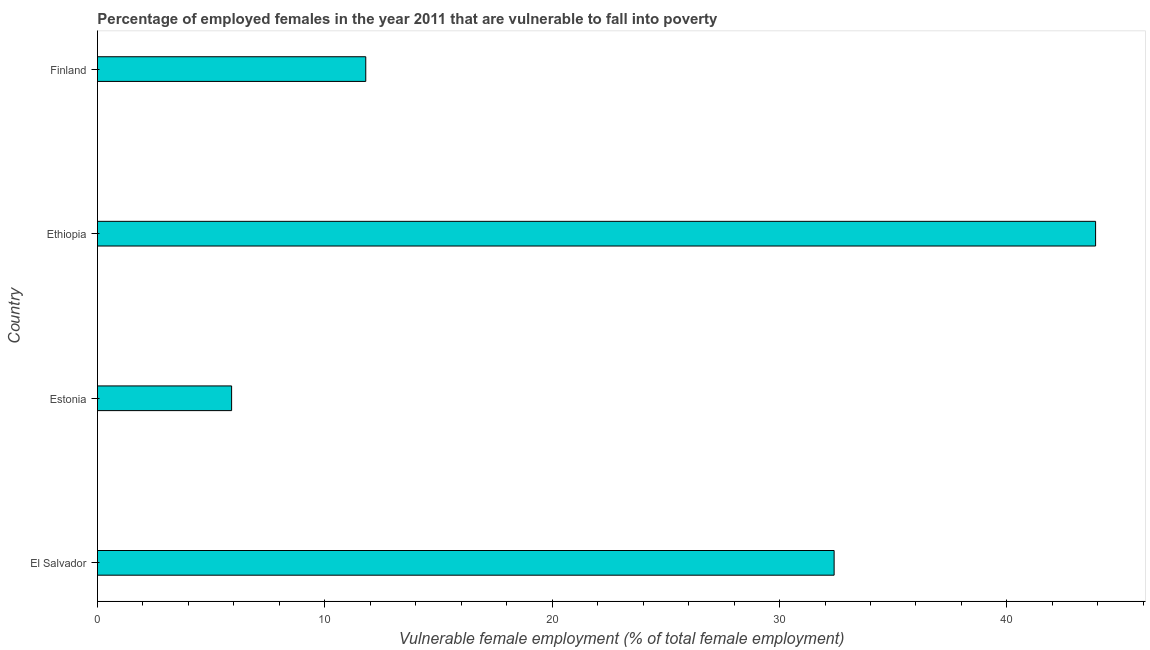What is the title of the graph?
Keep it short and to the point. Percentage of employed females in the year 2011 that are vulnerable to fall into poverty. What is the label or title of the X-axis?
Your answer should be compact. Vulnerable female employment (% of total female employment). What is the percentage of employed females who are vulnerable to fall into poverty in Finland?
Your response must be concise. 11.8. Across all countries, what is the maximum percentage of employed females who are vulnerable to fall into poverty?
Give a very brief answer. 43.9. Across all countries, what is the minimum percentage of employed females who are vulnerable to fall into poverty?
Your answer should be very brief. 5.9. In which country was the percentage of employed females who are vulnerable to fall into poverty maximum?
Offer a very short reply. Ethiopia. In which country was the percentage of employed females who are vulnerable to fall into poverty minimum?
Make the answer very short. Estonia. What is the sum of the percentage of employed females who are vulnerable to fall into poverty?
Your response must be concise. 94. What is the median percentage of employed females who are vulnerable to fall into poverty?
Your answer should be compact. 22.1. What is the ratio of the percentage of employed females who are vulnerable to fall into poverty in Estonia to that in Ethiopia?
Offer a very short reply. 0.13. Is the sum of the percentage of employed females who are vulnerable to fall into poverty in Estonia and Finland greater than the maximum percentage of employed females who are vulnerable to fall into poverty across all countries?
Offer a terse response. No. What is the difference between the highest and the lowest percentage of employed females who are vulnerable to fall into poverty?
Provide a short and direct response. 38. In how many countries, is the percentage of employed females who are vulnerable to fall into poverty greater than the average percentage of employed females who are vulnerable to fall into poverty taken over all countries?
Keep it short and to the point. 2. How many bars are there?
Give a very brief answer. 4. How many countries are there in the graph?
Provide a succinct answer. 4. What is the Vulnerable female employment (% of total female employment) in El Salvador?
Provide a short and direct response. 32.4. What is the Vulnerable female employment (% of total female employment) in Estonia?
Ensure brevity in your answer.  5.9. What is the Vulnerable female employment (% of total female employment) of Ethiopia?
Your response must be concise. 43.9. What is the Vulnerable female employment (% of total female employment) of Finland?
Your answer should be compact. 11.8. What is the difference between the Vulnerable female employment (% of total female employment) in El Salvador and Ethiopia?
Keep it short and to the point. -11.5. What is the difference between the Vulnerable female employment (% of total female employment) in El Salvador and Finland?
Make the answer very short. 20.6. What is the difference between the Vulnerable female employment (% of total female employment) in Estonia and Ethiopia?
Make the answer very short. -38. What is the difference between the Vulnerable female employment (% of total female employment) in Estonia and Finland?
Your response must be concise. -5.9. What is the difference between the Vulnerable female employment (% of total female employment) in Ethiopia and Finland?
Offer a terse response. 32.1. What is the ratio of the Vulnerable female employment (% of total female employment) in El Salvador to that in Estonia?
Make the answer very short. 5.49. What is the ratio of the Vulnerable female employment (% of total female employment) in El Salvador to that in Ethiopia?
Your answer should be very brief. 0.74. What is the ratio of the Vulnerable female employment (% of total female employment) in El Salvador to that in Finland?
Make the answer very short. 2.75. What is the ratio of the Vulnerable female employment (% of total female employment) in Estonia to that in Ethiopia?
Provide a short and direct response. 0.13. What is the ratio of the Vulnerable female employment (% of total female employment) in Estonia to that in Finland?
Offer a terse response. 0.5. What is the ratio of the Vulnerable female employment (% of total female employment) in Ethiopia to that in Finland?
Offer a very short reply. 3.72. 